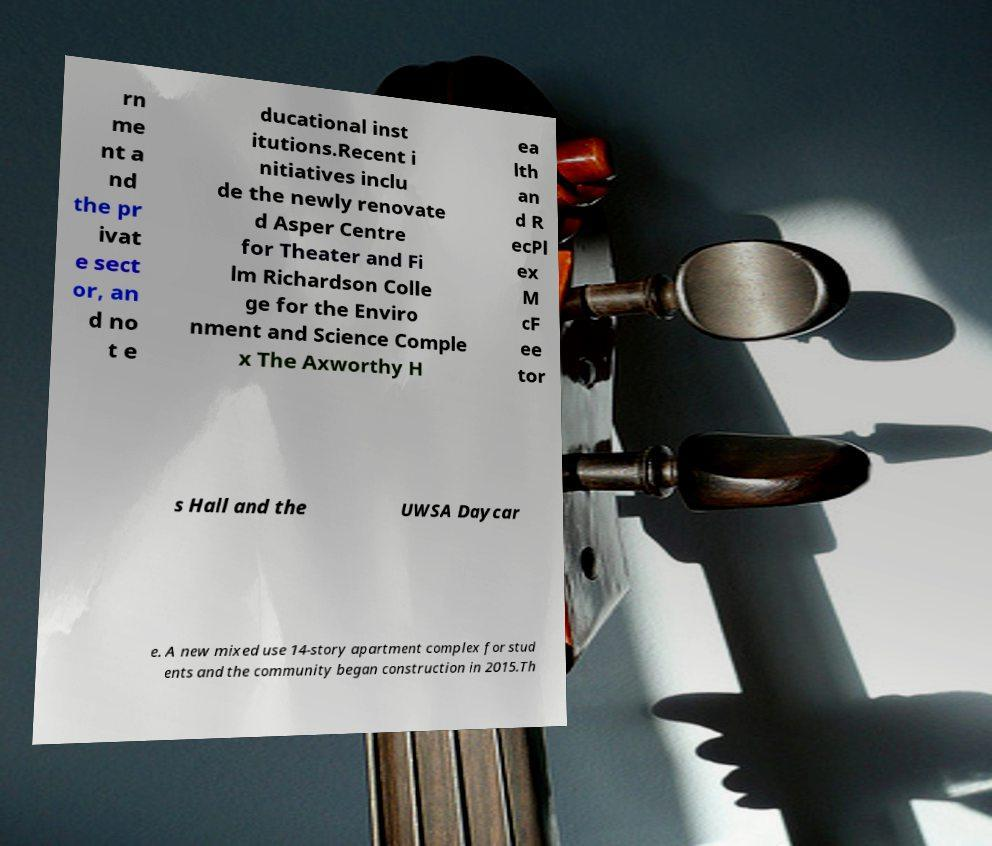For documentation purposes, I need the text within this image transcribed. Could you provide that? rn me nt a nd the pr ivat e sect or, an d no t e ducational inst itutions.Recent i nitiatives inclu de the newly renovate d Asper Centre for Theater and Fi lm Richardson Colle ge for the Enviro nment and Science Comple x The Axworthy H ea lth an d R ecPl ex M cF ee tor s Hall and the UWSA Daycar e. A new mixed use 14-story apartment complex for stud ents and the community began construction in 2015.Th 